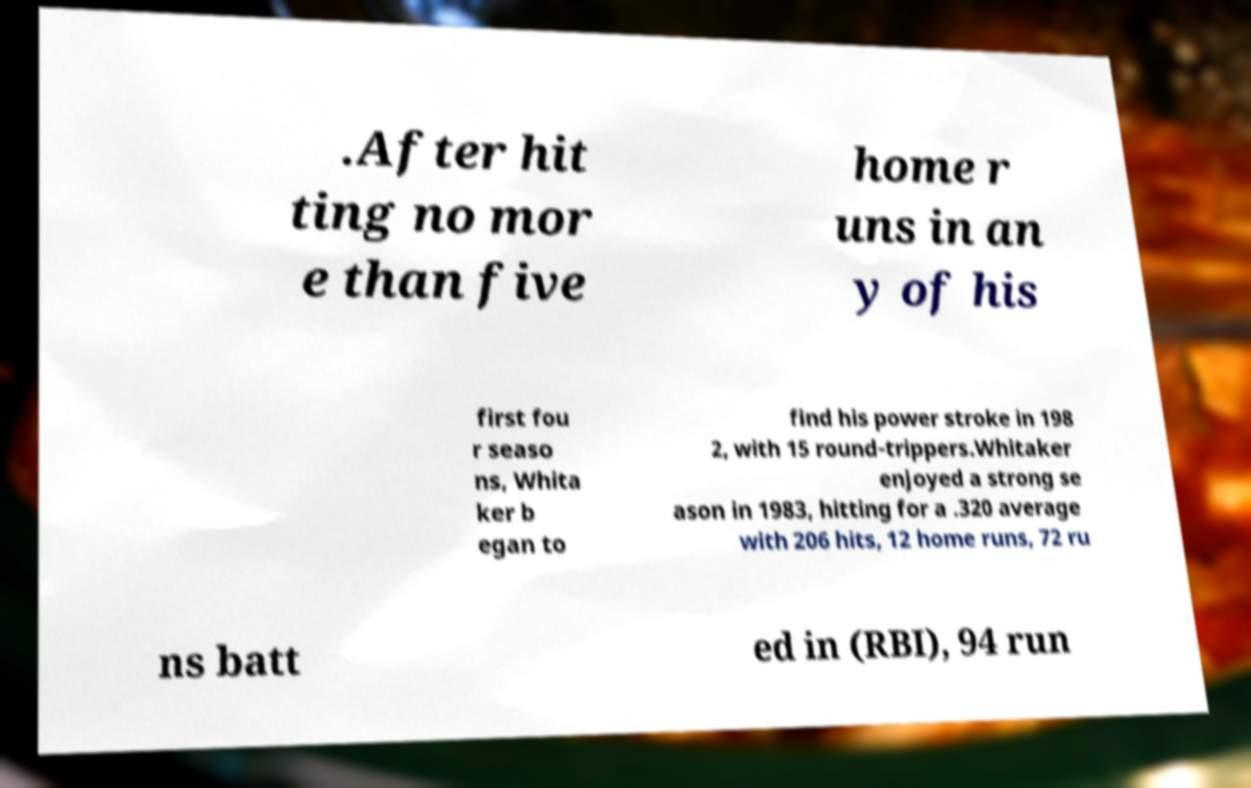There's text embedded in this image that I need extracted. Can you transcribe it verbatim? .After hit ting no mor e than five home r uns in an y of his first fou r seaso ns, Whita ker b egan to find his power stroke in 198 2, with 15 round-trippers.Whitaker enjoyed a strong se ason in 1983, hitting for a .320 average with 206 hits, 12 home runs, 72 ru ns batt ed in (RBI), 94 run 